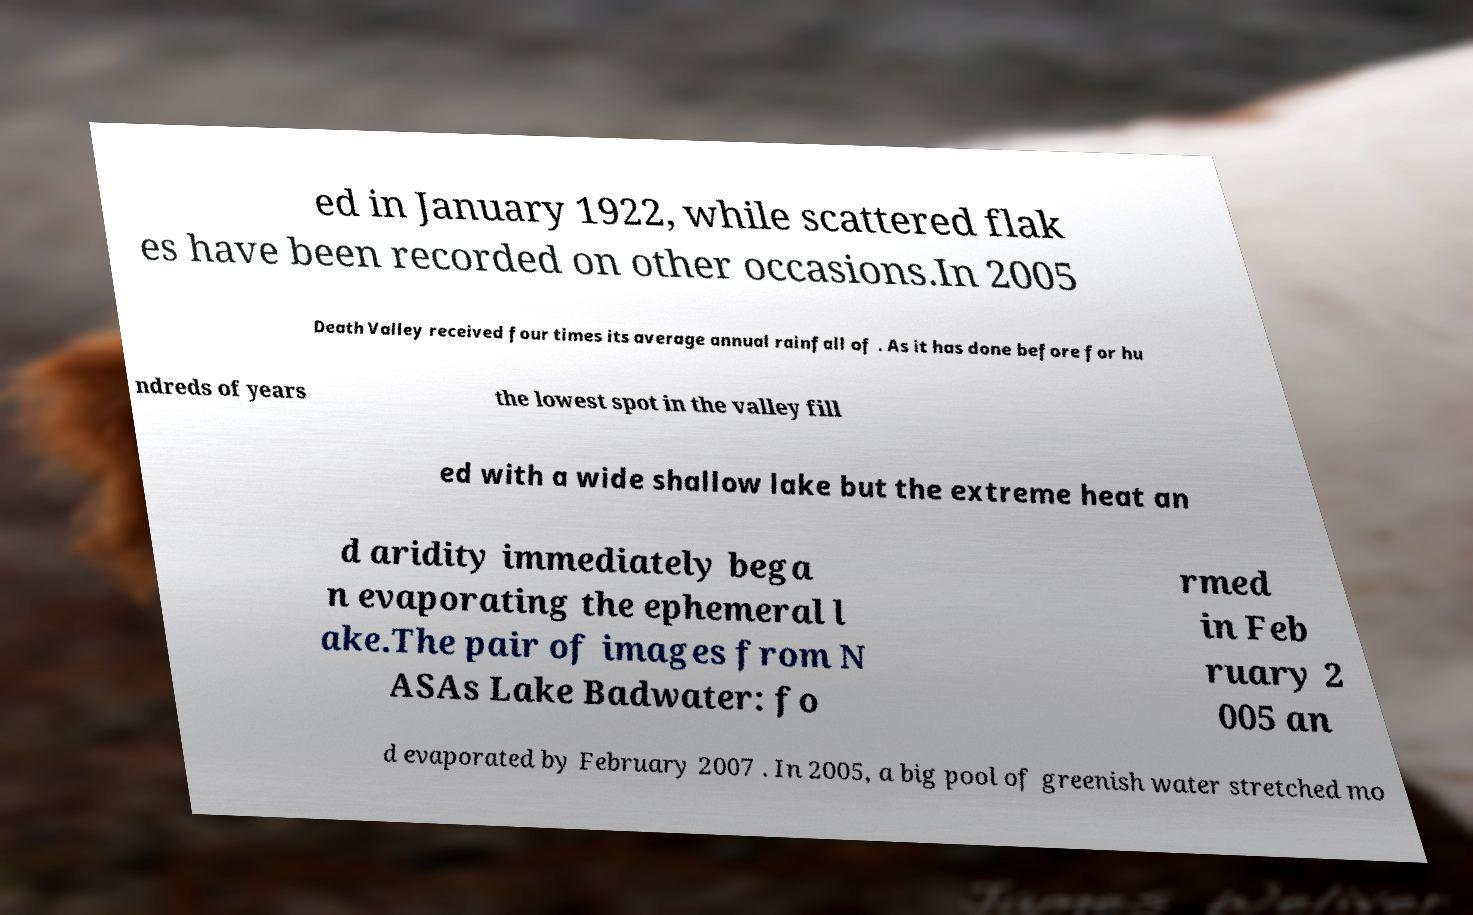Could you extract and type out the text from this image? ed in January 1922, while scattered flak es have been recorded on other occasions.In 2005 Death Valley received four times its average annual rainfall of . As it has done before for hu ndreds of years the lowest spot in the valley fill ed with a wide shallow lake but the extreme heat an d aridity immediately bega n evaporating the ephemeral l ake.The pair of images from N ASAs Lake Badwater: fo rmed in Feb ruary 2 005 an d evaporated by February 2007 . In 2005, a big pool of greenish water stretched mo 